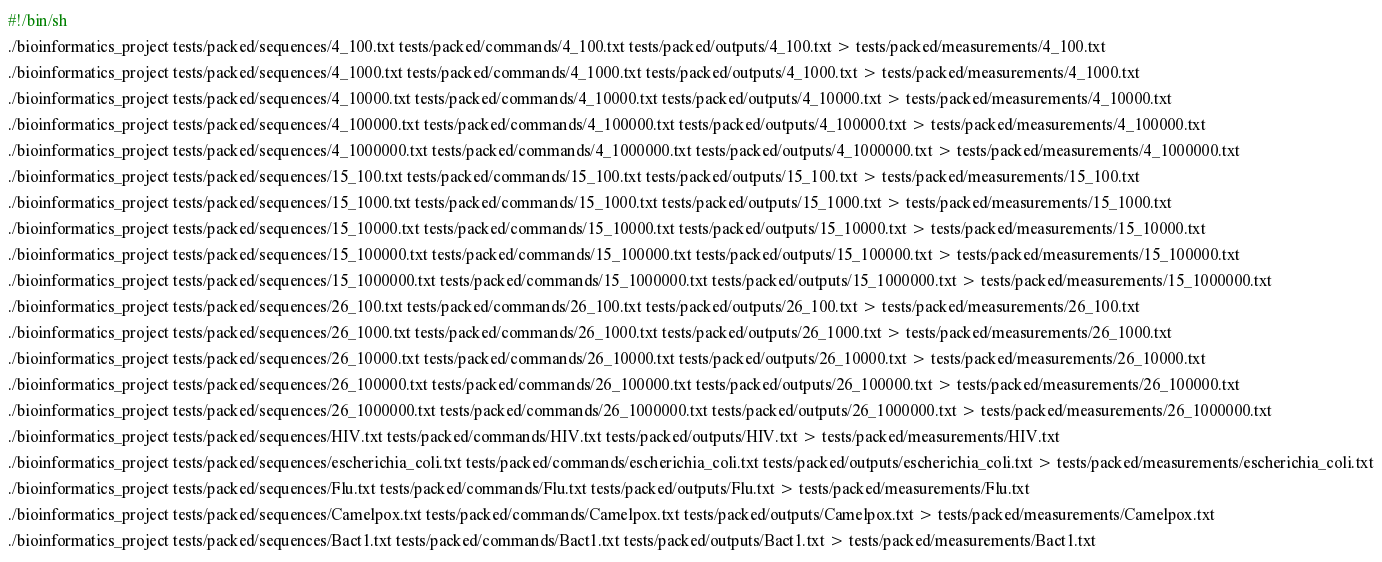Convert code to text. <code><loc_0><loc_0><loc_500><loc_500><_Bash_>#!/bin/sh
./bioinformatics_project tests/packed/sequences/4_100.txt tests/packed/commands/4_100.txt tests/packed/outputs/4_100.txt > tests/packed/measurements/4_100.txt
./bioinformatics_project tests/packed/sequences/4_1000.txt tests/packed/commands/4_1000.txt tests/packed/outputs/4_1000.txt > tests/packed/measurements/4_1000.txt
./bioinformatics_project tests/packed/sequences/4_10000.txt tests/packed/commands/4_10000.txt tests/packed/outputs/4_10000.txt > tests/packed/measurements/4_10000.txt
./bioinformatics_project tests/packed/sequences/4_100000.txt tests/packed/commands/4_100000.txt tests/packed/outputs/4_100000.txt > tests/packed/measurements/4_100000.txt
./bioinformatics_project tests/packed/sequences/4_1000000.txt tests/packed/commands/4_1000000.txt tests/packed/outputs/4_1000000.txt > tests/packed/measurements/4_1000000.txt
./bioinformatics_project tests/packed/sequences/15_100.txt tests/packed/commands/15_100.txt tests/packed/outputs/15_100.txt > tests/packed/measurements/15_100.txt
./bioinformatics_project tests/packed/sequences/15_1000.txt tests/packed/commands/15_1000.txt tests/packed/outputs/15_1000.txt > tests/packed/measurements/15_1000.txt
./bioinformatics_project tests/packed/sequences/15_10000.txt tests/packed/commands/15_10000.txt tests/packed/outputs/15_10000.txt > tests/packed/measurements/15_10000.txt
./bioinformatics_project tests/packed/sequences/15_100000.txt tests/packed/commands/15_100000.txt tests/packed/outputs/15_100000.txt > tests/packed/measurements/15_100000.txt
./bioinformatics_project tests/packed/sequences/15_1000000.txt tests/packed/commands/15_1000000.txt tests/packed/outputs/15_1000000.txt > tests/packed/measurements/15_1000000.txt
./bioinformatics_project tests/packed/sequences/26_100.txt tests/packed/commands/26_100.txt tests/packed/outputs/26_100.txt > tests/packed/measurements/26_100.txt
./bioinformatics_project tests/packed/sequences/26_1000.txt tests/packed/commands/26_1000.txt tests/packed/outputs/26_1000.txt > tests/packed/measurements/26_1000.txt
./bioinformatics_project tests/packed/sequences/26_10000.txt tests/packed/commands/26_10000.txt tests/packed/outputs/26_10000.txt > tests/packed/measurements/26_10000.txt
./bioinformatics_project tests/packed/sequences/26_100000.txt tests/packed/commands/26_100000.txt tests/packed/outputs/26_100000.txt > tests/packed/measurements/26_100000.txt
./bioinformatics_project tests/packed/sequences/26_1000000.txt tests/packed/commands/26_1000000.txt tests/packed/outputs/26_1000000.txt > tests/packed/measurements/26_1000000.txt
./bioinformatics_project tests/packed/sequences/HIV.txt tests/packed/commands/HIV.txt tests/packed/outputs/HIV.txt > tests/packed/measurements/HIV.txt
./bioinformatics_project tests/packed/sequences/escherichia_coli.txt tests/packed/commands/escherichia_coli.txt tests/packed/outputs/escherichia_coli.txt > tests/packed/measurements/escherichia_coli.txt
./bioinformatics_project tests/packed/sequences/Flu.txt tests/packed/commands/Flu.txt tests/packed/outputs/Flu.txt > tests/packed/measurements/Flu.txt
./bioinformatics_project tests/packed/sequences/Camelpox.txt tests/packed/commands/Camelpox.txt tests/packed/outputs/Camelpox.txt > tests/packed/measurements/Camelpox.txt
./bioinformatics_project tests/packed/sequences/Bact1.txt tests/packed/commands/Bact1.txt tests/packed/outputs/Bact1.txt > tests/packed/measurements/Bact1.txt
</code> 